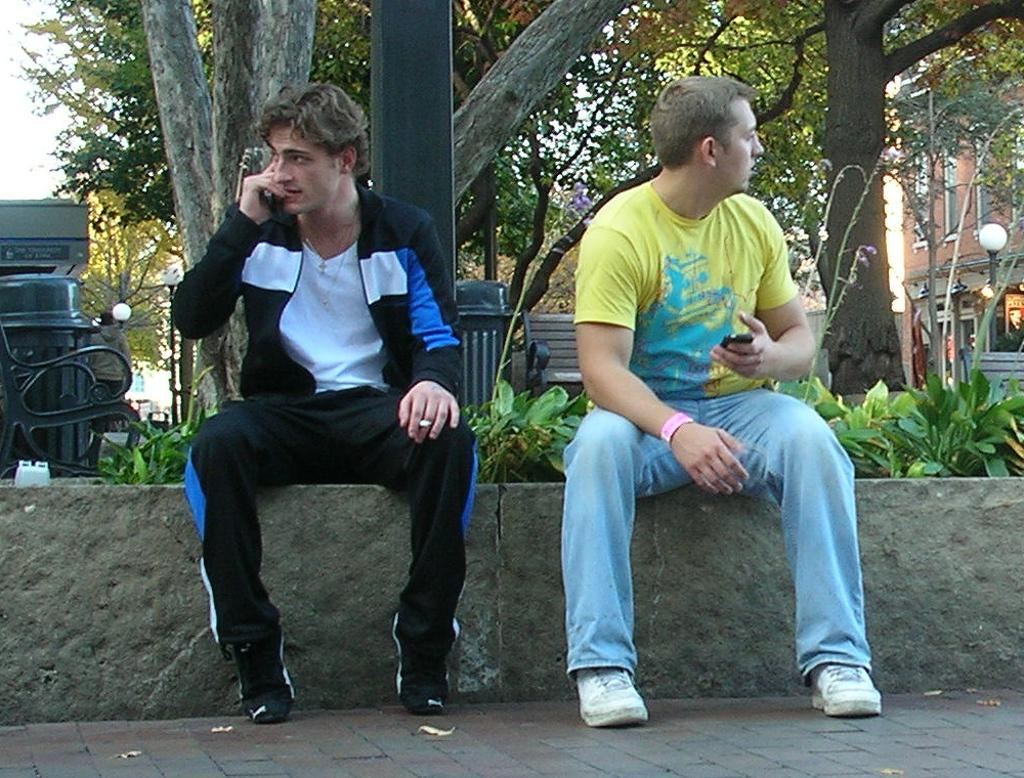How many people are sitting on the stone in the image? There are two persons sitting on a stone in the image. What can be seen in the background of the image? Trees, buildings, a street light, plants, a dustbin, and the sky are visible in the background of the image. What might be used for disposing of waste in the image? A dustbin is present in the background of the image. What type of juice is being served in the image? There is no juice present in the image. Can you tell me how many crackers are on the stone with the two persons? There are no crackers visible in the image; only the two persons sitting on the stone are present. 